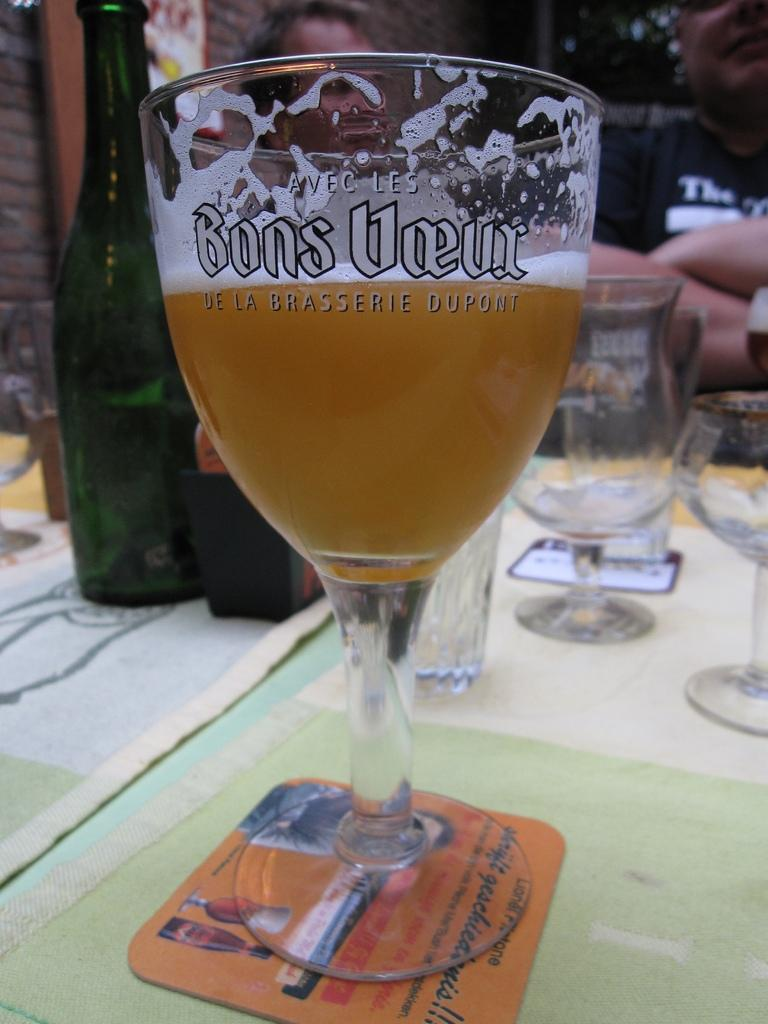<image>
Share a concise interpretation of the image provided. A glass of beer with Bons voeur written on in 